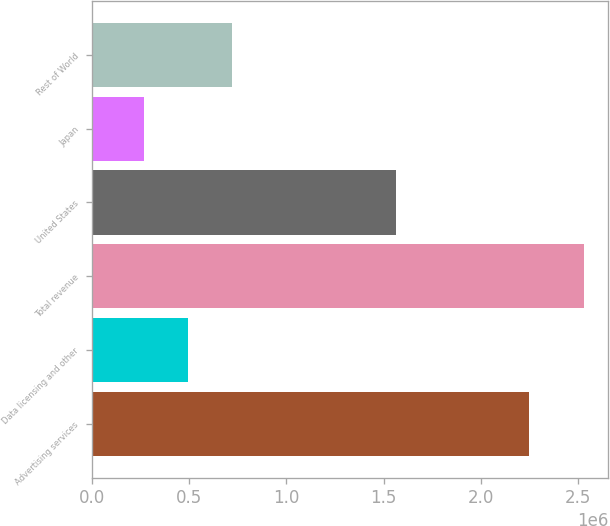Convert chart. <chart><loc_0><loc_0><loc_500><loc_500><bar_chart><fcel>Advertising services<fcel>Data licensing and other<fcel>Total revenue<fcel>United States<fcel>Japan<fcel>Rest of World<nl><fcel>2.24805e+06<fcel>494608<fcel>2.52962e+06<fcel>1.56478e+06<fcel>268496<fcel>720721<nl></chart> 